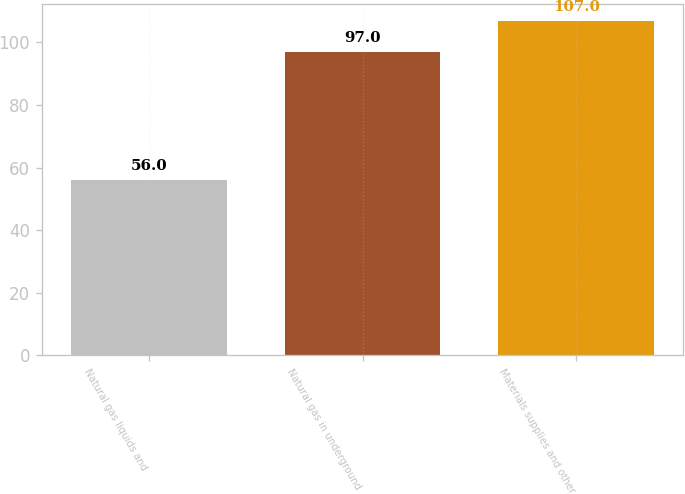Convert chart to OTSL. <chart><loc_0><loc_0><loc_500><loc_500><bar_chart><fcel>Natural gas liquids and<fcel>Natural gas in underground<fcel>Materials supplies and other<nl><fcel>56<fcel>97<fcel>107<nl></chart> 